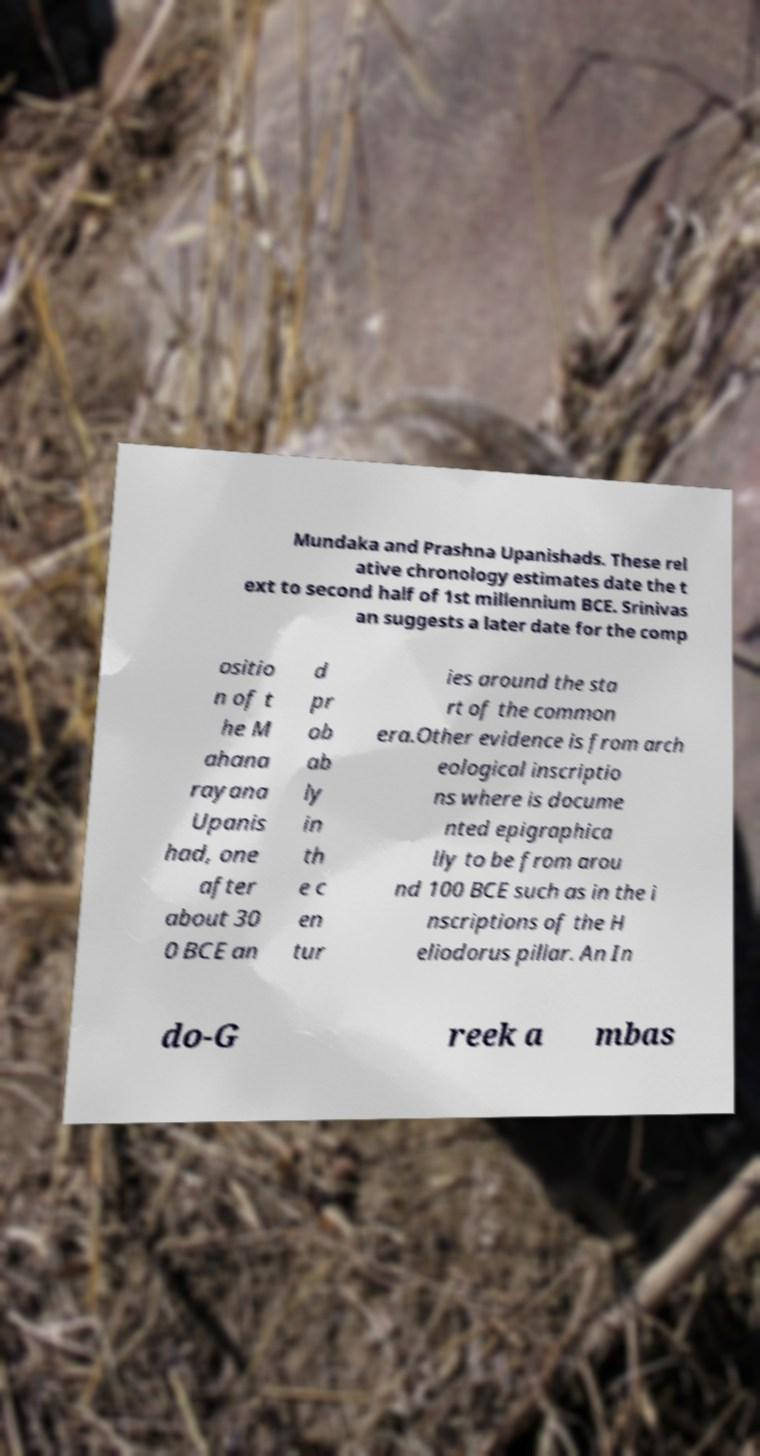Can you read and provide the text displayed in the image?This photo seems to have some interesting text. Can you extract and type it out for me? Mundaka and Prashna Upanishads. These rel ative chronology estimates date the t ext to second half of 1st millennium BCE. Srinivas an suggests a later date for the comp ositio n of t he M ahana rayana Upanis had, one after about 30 0 BCE an d pr ob ab ly in th e c en tur ies around the sta rt of the common era.Other evidence is from arch eological inscriptio ns where is docume nted epigraphica lly to be from arou nd 100 BCE such as in the i nscriptions of the H eliodorus pillar. An In do-G reek a mbas 